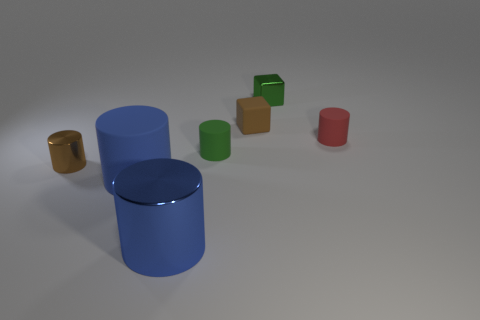How many other objects are there of the same material as the small brown cylinder?
Your answer should be compact. 2. Do the tiny metallic cylinder and the tiny matte cylinder that is on the left side of the small red rubber thing have the same color?
Your answer should be compact. No. Is the number of tiny brown cylinders that are right of the small shiny cylinder greater than the number of blue metallic blocks?
Offer a terse response. No. There is a rubber cylinder that is in front of the tiny green object in front of the brown matte block; what number of green shiny objects are in front of it?
Offer a very short reply. 0. There is a small brown thing that is right of the brown cylinder; does it have the same shape as the brown metal object?
Offer a terse response. No. What material is the tiny green cube that is behind the blue shiny thing?
Your answer should be compact. Metal. What shape is the matte object that is both to the left of the tiny red cylinder and right of the green rubber cylinder?
Ensure brevity in your answer.  Cube. What is the red object made of?
Offer a terse response. Rubber. What number of spheres are either green shiny objects or small red things?
Your response must be concise. 0. Are the small green cube and the green cylinder made of the same material?
Your answer should be compact. No. 